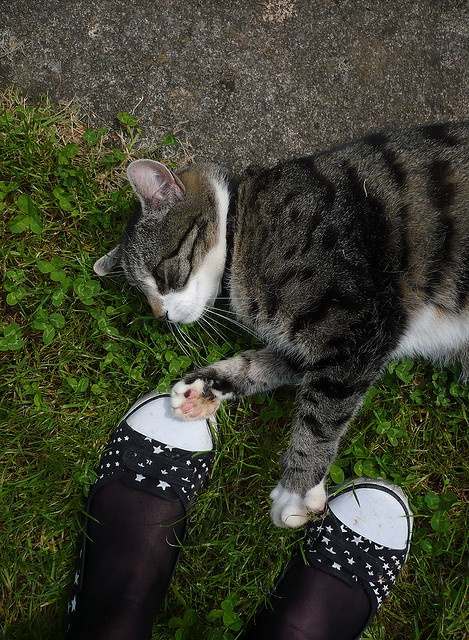Describe the objects in this image and their specific colors. I can see cat in black, gray, and darkgray tones and people in black, lightgray, gray, and darkgray tones in this image. 